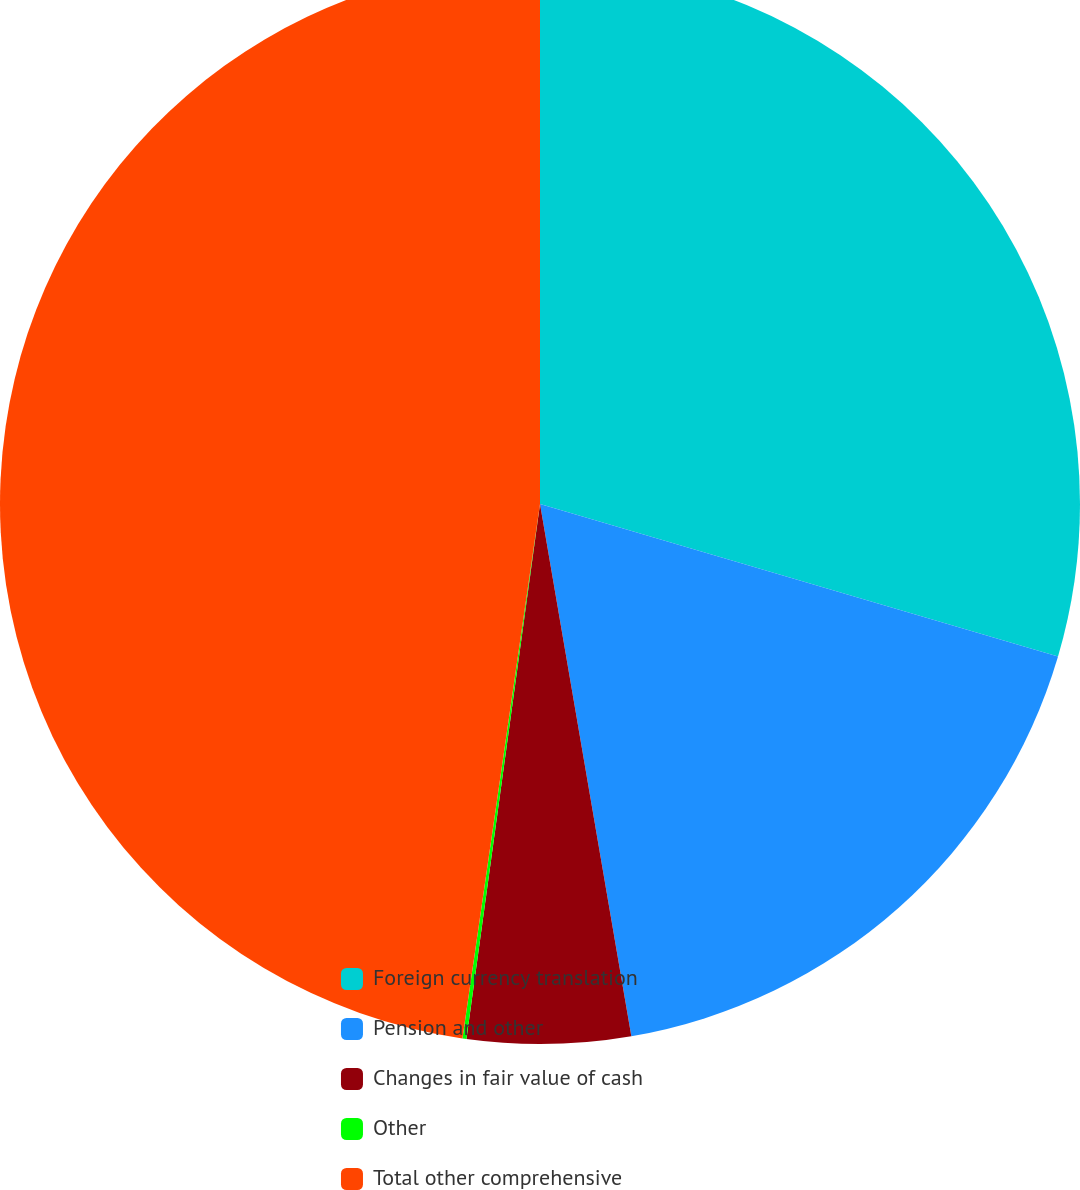<chart> <loc_0><loc_0><loc_500><loc_500><pie_chart><fcel>Foreign currency translation<fcel>Pension and other<fcel>Changes in fair value of cash<fcel>Other<fcel>Total other comprehensive<nl><fcel>29.56%<fcel>17.74%<fcel>4.88%<fcel>0.12%<fcel>47.71%<nl></chart> 